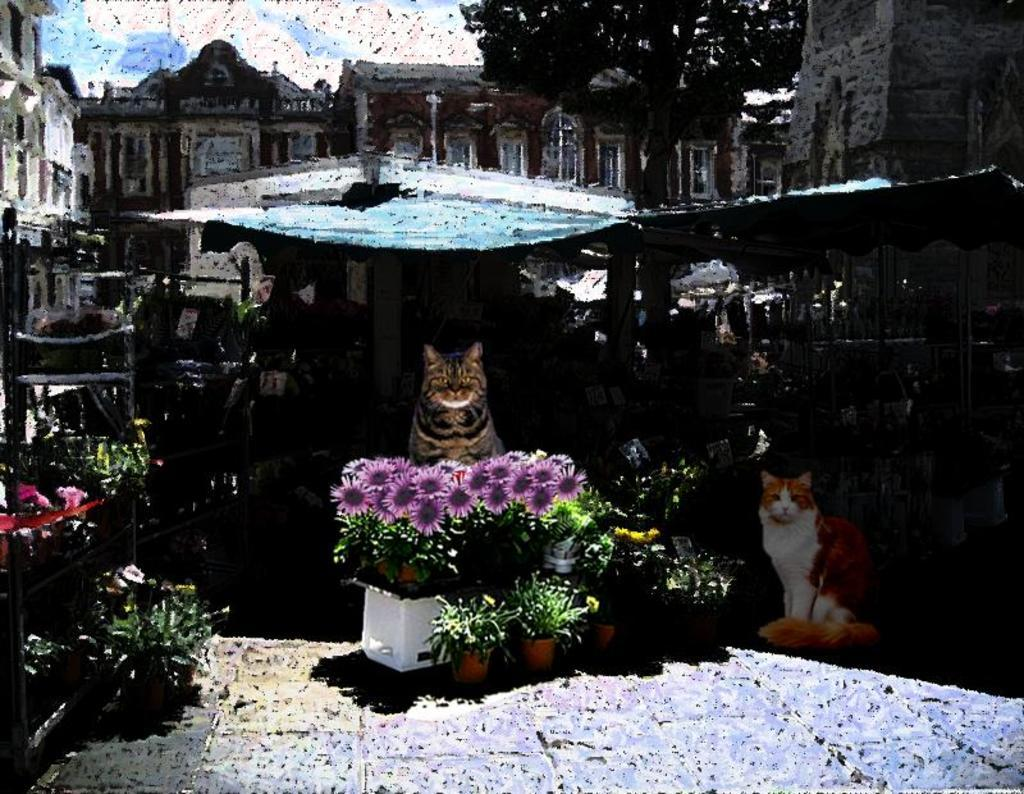What type of structures can be seen in the image? There are buildings in the image. What type of vegetation is present in the image? There are trees, plants, and flowers in the image. Are there any living creatures in the image? Yes, there are cats in the image. What can be seen in the background of the image? The sky is visible in the background of the image. How does the wind affect the buildings in the image? There is no mention of wind in the image, so we cannot determine its effect on the buildings. 